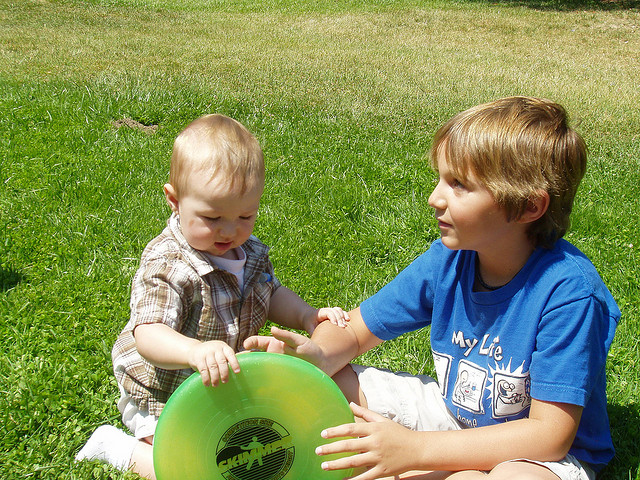<image>Are these two brothers? I don't know if these two are brothers. Are these two brothers? I don't know if these two people are brothers. They might be, but I can't say for sure. 